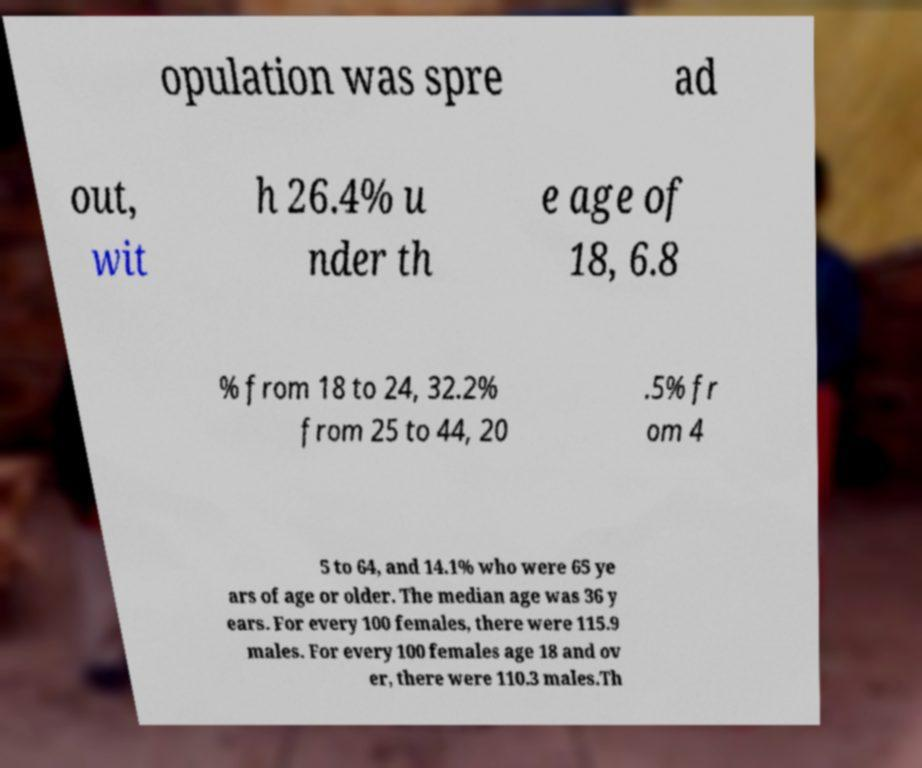Please identify and transcribe the text found in this image. opulation was spre ad out, wit h 26.4% u nder th e age of 18, 6.8 % from 18 to 24, 32.2% from 25 to 44, 20 .5% fr om 4 5 to 64, and 14.1% who were 65 ye ars of age or older. The median age was 36 y ears. For every 100 females, there were 115.9 males. For every 100 females age 18 and ov er, there were 110.3 males.Th 